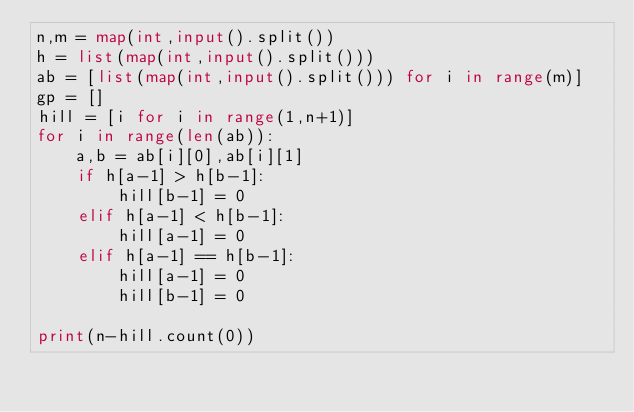<code> <loc_0><loc_0><loc_500><loc_500><_Python_>n,m = map(int,input().split())
h = list(map(int,input().split()))
ab = [list(map(int,input().split())) for i in range(m)]
gp = []
hill = [i for i in range(1,n+1)]
for i in range(len(ab)):
    a,b = ab[i][0],ab[i][1]
    if h[a-1] > h[b-1]:
        hill[b-1] = 0
    elif h[a-1] < h[b-1]:
        hill[a-1] = 0
    elif h[a-1] == h[b-1]:
        hill[a-1] = 0
        hill[b-1] = 0

print(n-hill.count(0))
</code> 